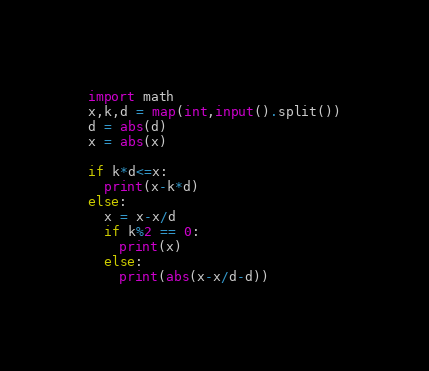Convert code to text. <code><loc_0><loc_0><loc_500><loc_500><_Python_>import math
x,k,d = map(int,input().split())
d = abs(d)
x = abs(x)

if k*d<=x:
  print(x-k*d)
else:
  x = x-x/d
  if k%2 == 0:
    print(x)
  else:
    print(abs(x-x/d-d))

</code> 